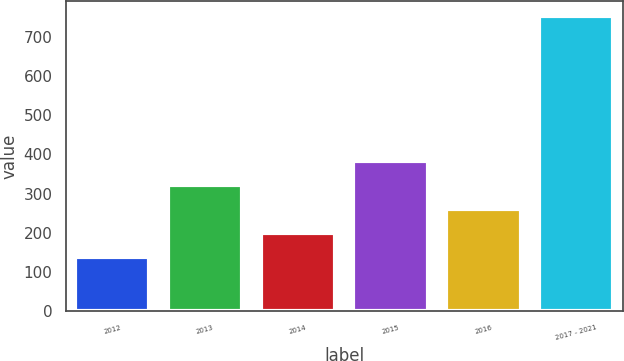<chart> <loc_0><loc_0><loc_500><loc_500><bar_chart><fcel>2012<fcel>2013<fcel>2014<fcel>2015<fcel>2016<fcel>2017 - 2021<nl><fcel>137<fcel>321.8<fcel>198.6<fcel>383.4<fcel>260.2<fcel>753<nl></chart> 